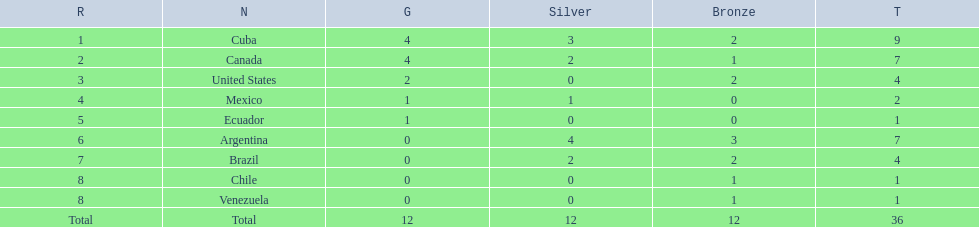Which countries won medals at the 2011 pan american games for the canoeing event? Cuba, Canada, United States, Mexico, Ecuador, Argentina, Brazil, Chile, Venezuela. Which of these countries won bronze medals? Cuba, Canada, United States, Argentina, Brazil, Chile, Venezuela. Of these countries, which won the most bronze medals? Argentina. 